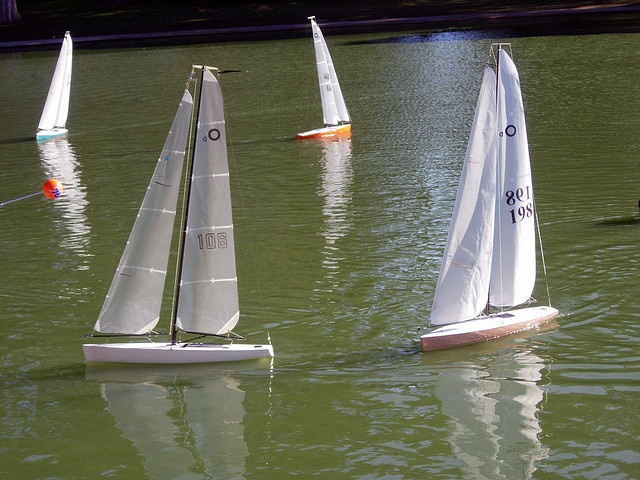Describe the objects in this image and their specific colors. I can see boat in black, darkgray, gray, darkgreen, and lightgray tones, boat in black, lightgray, darkgray, and gray tones, boat in black, white, brown, gray, and tan tones, boat in black, white, gray, and darkgray tones, and boat in black, white, tan, lightpink, and gray tones in this image. 